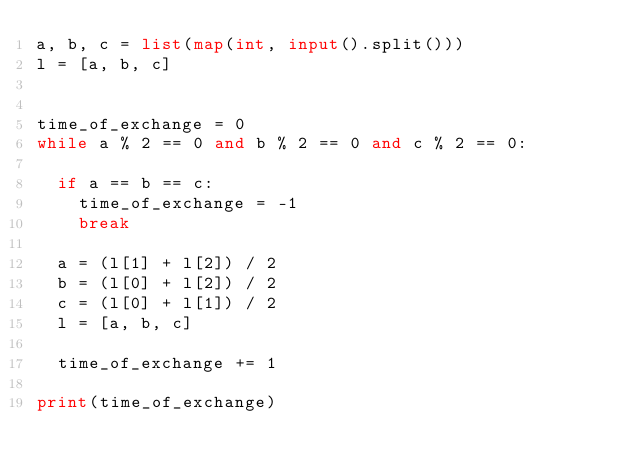Convert code to text. <code><loc_0><loc_0><loc_500><loc_500><_Python_>a, b, c = list(map(int, input().split()))
l = [a, b, c]


time_of_exchange = 0
while a % 2 == 0 and b % 2 == 0 and c % 2 == 0:
	
	if a == b == c:
		time_of_exchange = -1
		break
	
	a = (l[1] + l[2]) / 2
	b = (l[0] + l[2]) / 2
	c = (l[0] + l[1]) / 2
	l = [a, b, c]
	
	time_of_exchange += 1
	
print(time_of_exchange)

</code> 